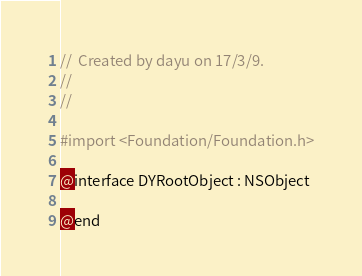<code> <loc_0><loc_0><loc_500><loc_500><_C_>//  Created by dayu on 17/3/9.
//
//

#import <Foundation/Foundation.h>

@interface DYRootObject : NSObject

@end
</code> 